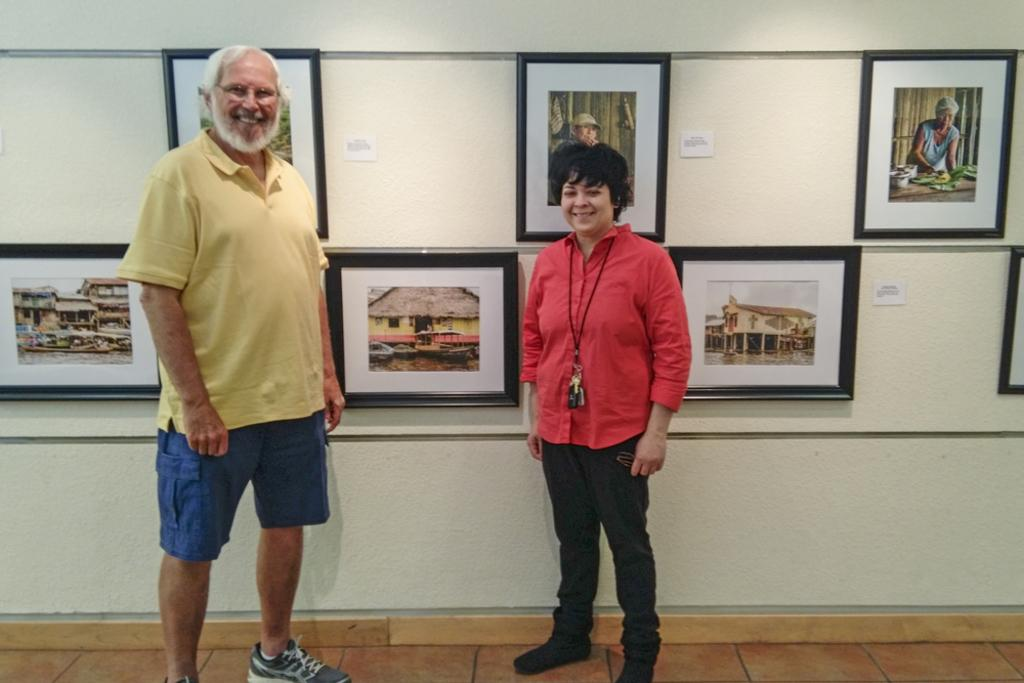How many people are present in the image? There are two people, a man and a woman, present in the image. What are the positions of the man and woman in the image? Both the man and woman are standing on the floor in the image. What can be seen on the wall in the image? Wall hangings are attached to the wall in the image. What type of spoon is being used to serve the dinner in the image? There is no dinner or spoon present in the image. 